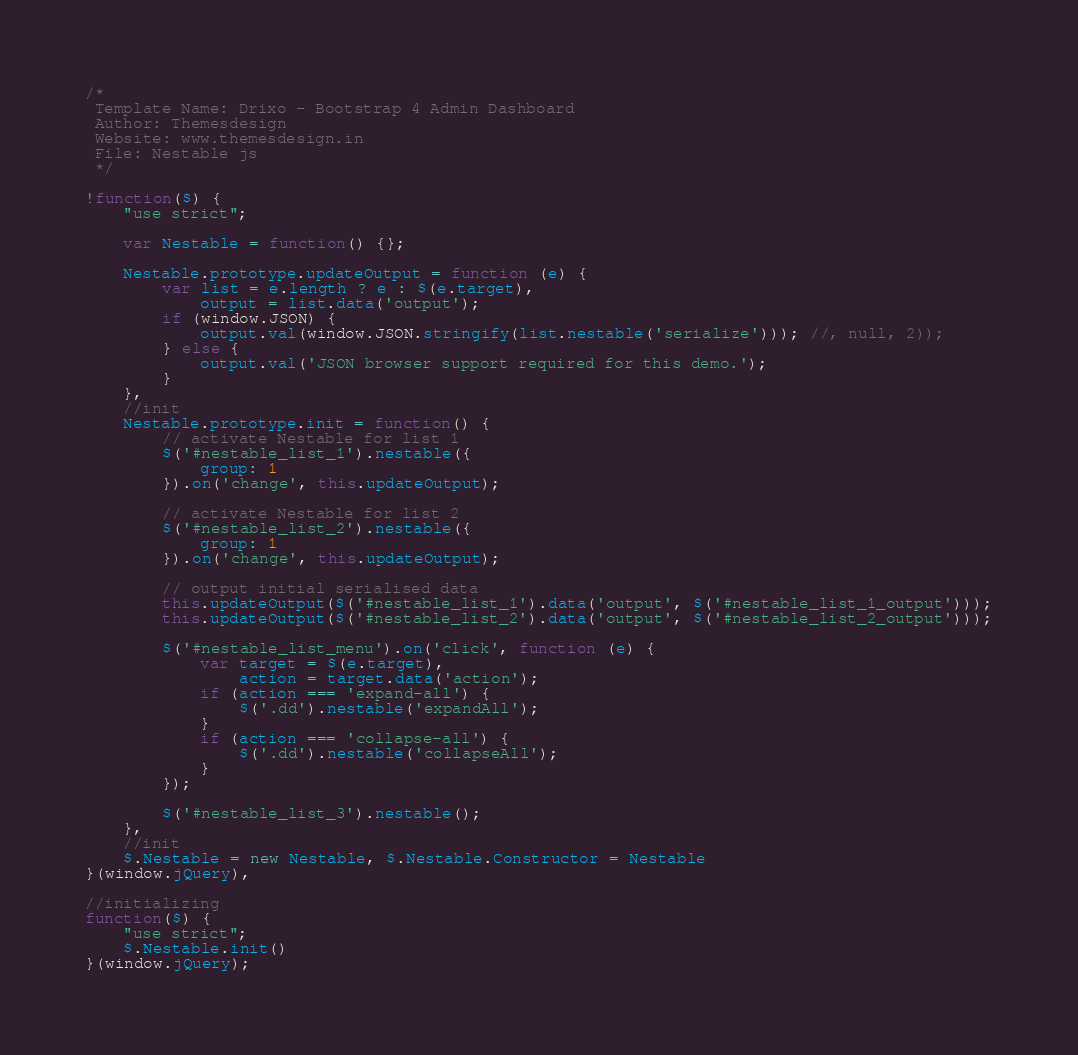<code> <loc_0><loc_0><loc_500><loc_500><_JavaScript_>/*
 Template Name: Drixo - Bootstrap 4 Admin Dashboard
 Author: Themesdesign
 Website: www.themesdesign.in
 File: Nestable js
 */

!function($) {
    "use strict";

    var Nestable = function() {};

    Nestable.prototype.updateOutput = function (e) {
        var list = e.length ? e : $(e.target),
            output = list.data('output');
        if (window.JSON) {
            output.val(window.JSON.stringify(list.nestable('serialize'))); //, null, 2));
        } else {
            output.val('JSON browser support required for this demo.');
        }
    },
    //init
    Nestable.prototype.init = function() {
        // activate Nestable for list 1
        $('#nestable_list_1').nestable({
            group: 1
        }).on('change', this.updateOutput);

        // activate Nestable for list 2
        $('#nestable_list_2').nestable({
            group: 1
        }).on('change', this.updateOutput);

        // output initial serialised data
        this.updateOutput($('#nestable_list_1').data('output', $('#nestable_list_1_output')));
        this.updateOutput($('#nestable_list_2').data('output', $('#nestable_list_2_output')));

        $('#nestable_list_menu').on('click', function (e) {
            var target = $(e.target),
                action = target.data('action');
            if (action === 'expand-all') {
                $('.dd').nestable('expandAll');
            }
            if (action === 'collapse-all') {
                $('.dd').nestable('collapseAll');
            }
        });

        $('#nestable_list_3').nestable();
    },
    //init
    $.Nestable = new Nestable, $.Nestable.Constructor = Nestable
}(window.jQuery),

//initializing 
function($) {
    "use strict";
    $.Nestable.init()
}(window.jQuery);
</code> 